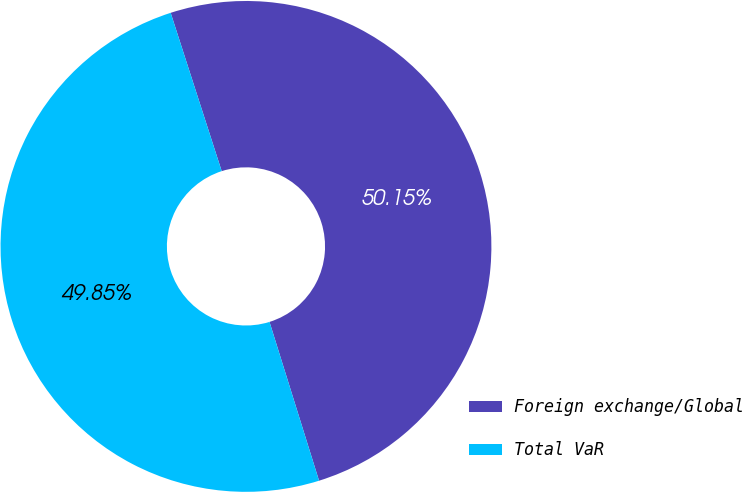<chart> <loc_0><loc_0><loc_500><loc_500><pie_chart><fcel>Foreign exchange/Global<fcel>Total VaR<nl><fcel>50.15%<fcel>49.85%<nl></chart> 